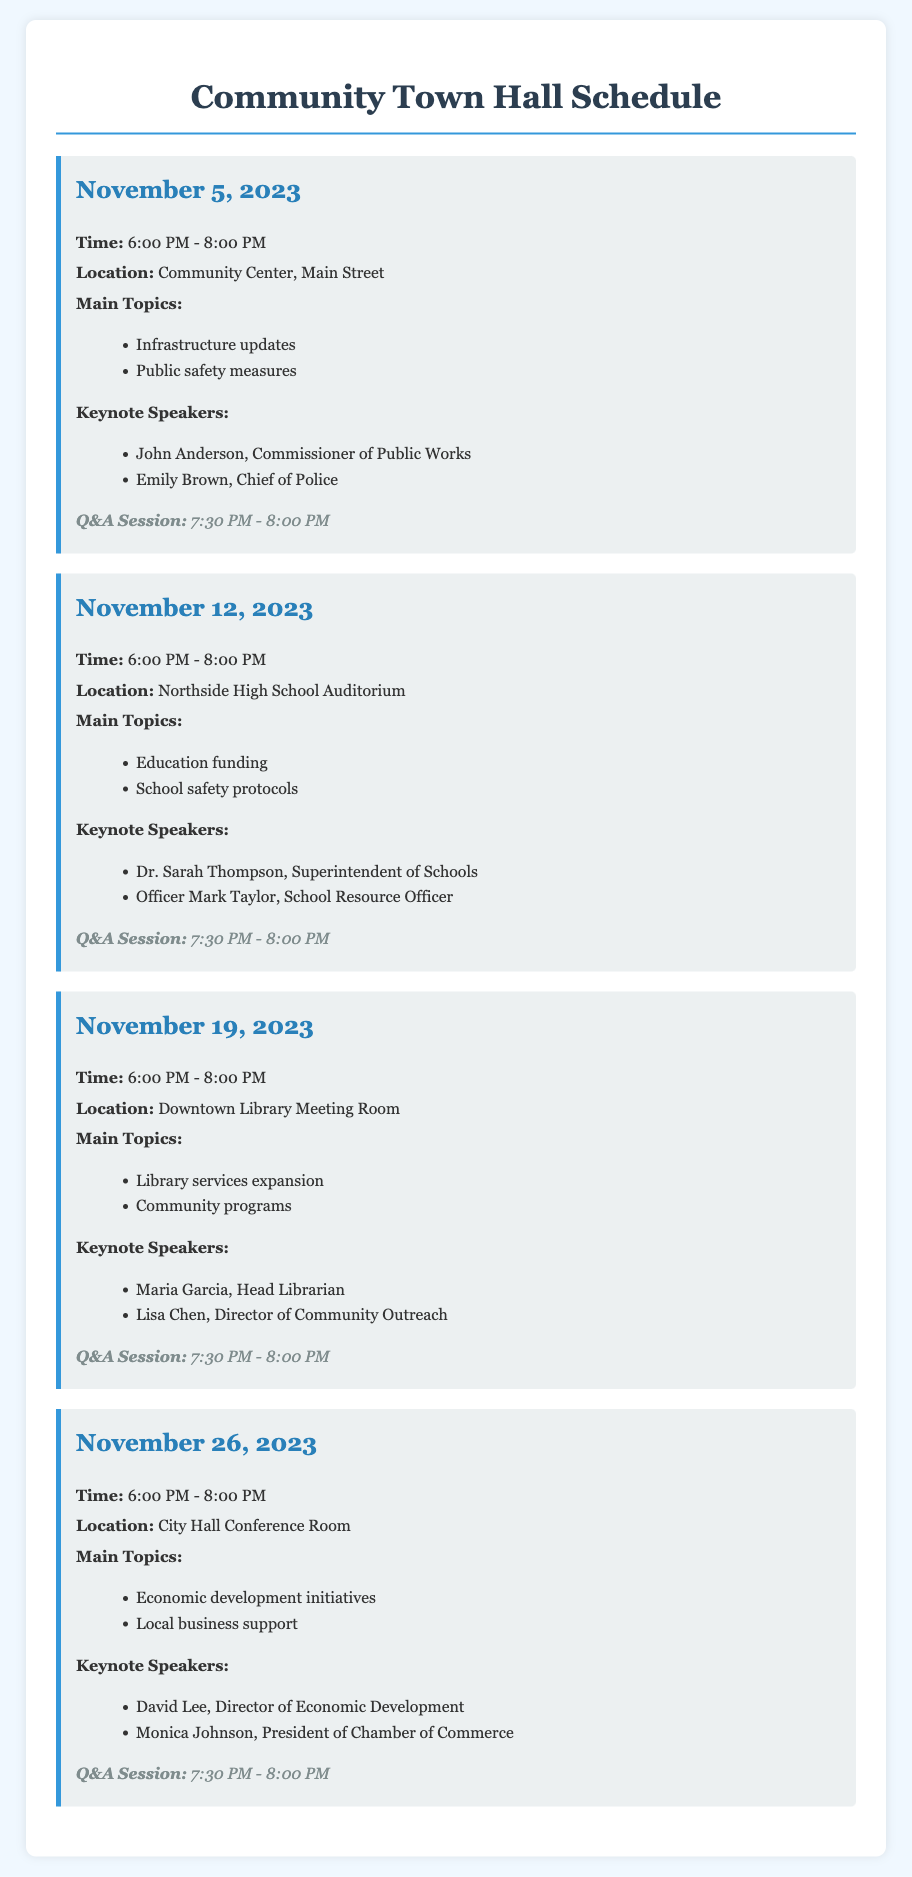What is the first town hall date? The first town hall date listed in the document is November 5, 2023.
Answer: November 5, 2023 How long is each town hall meeting scheduled to last? Each town hall meeting is scheduled from 6:00 PM to 8:00 PM, lasting for 2 hours.
Answer: 2 hours Who is the keynote speaker for the town hall on November 12, 2023? The keynote speakers for the town hall on November 12, 2023, are Dr. Sarah Thompson and Officer Mark Taylor.
Answer: Dr. Sarah Thompson, Officer Mark Taylor What is the main topic for the meeting on November 26, 2023? The main topics for the meeting on November 26, 2023, are economic development initiatives and local business support.
Answer: Economic development initiatives, local business support At what time does the Q&A session start at the town hall meetings? The Q&A session is scheduled to start at 7:30 PM during each town hall meeting.
Answer: 7:30 PM Which location will host the town hall on November 19, 2023? The town hall on November 19, 2023, will be held at the Downtown Library Meeting Room.
Answer: Downtown Library Meeting Room How many town hall meetings are listed in the document? There are four town hall meetings listed in the document.
Answer: Four What is the main focus of the town hall on November 5, 2023? The main topics for the town hall on November 5, 2023, include infrastructure updates and public safety measures.
Answer: Infrastructure updates, public safety measures 